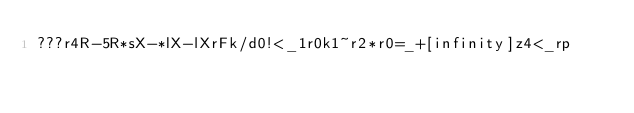Convert code to text. <code><loc_0><loc_0><loc_500><loc_500><_dc_>???r4R-5R*sX-*lX-lXrFk/d0!<_1r0k1~r2*r0=_+[infinity]z4<_rp</code> 